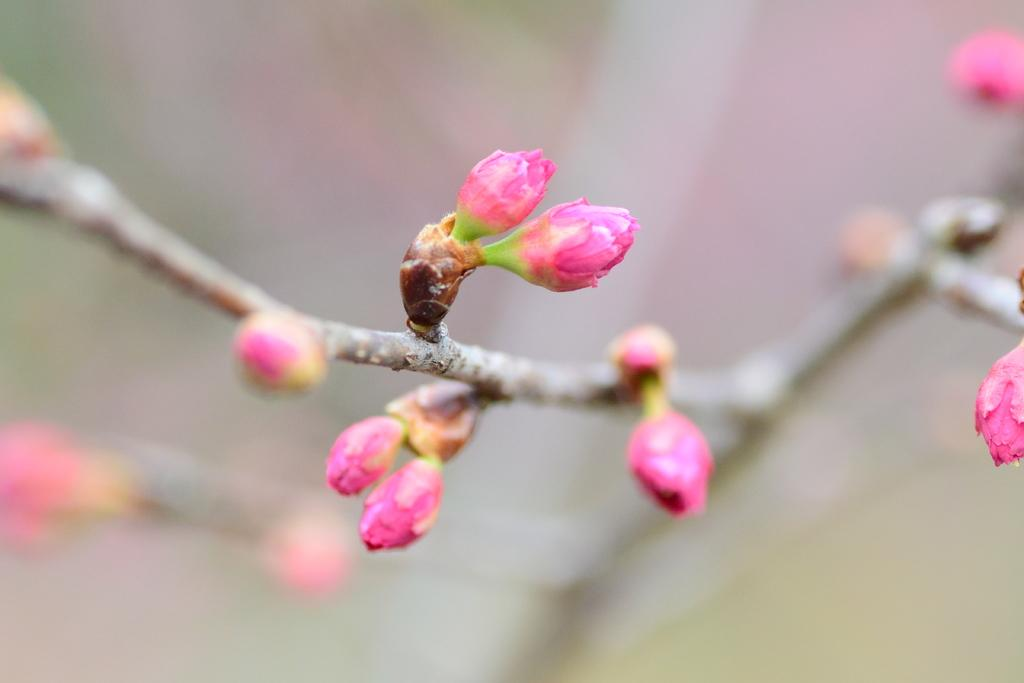What type of living organism can be seen in the image? There is a plant in the image. What type of dress is hanging on the hook near the plant in the image? There is no dress or hook present in the image; it only features a plant. 